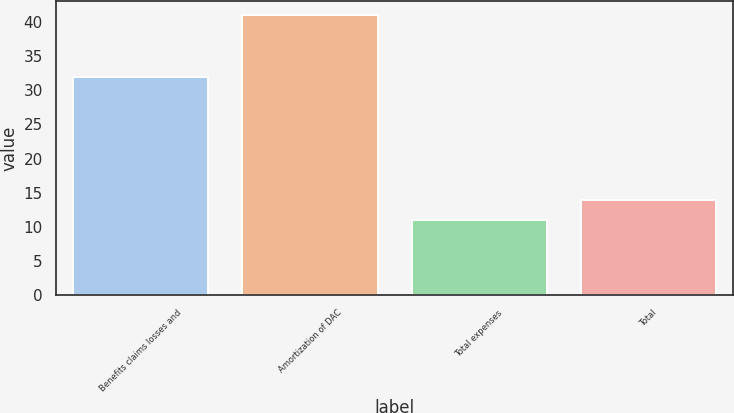Convert chart. <chart><loc_0><loc_0><loc_500><loc_500><bar_chart><fcel>Benefits claims losses and<fcel>Amortization of DAC<fcel>Total expenses<fcel>Total<nl><fcel>32<fcel>41<fcel>11<fcel>14<nl></chart> 